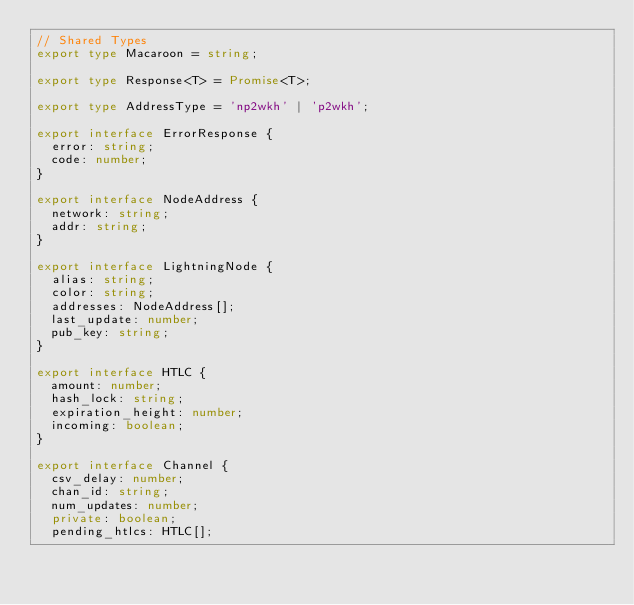<code> <loc_0><loc_0><loc_500><loc_500><_TypeScript_>// Shared Types
export type Macaroon = string;

export type Response<T> = Promise<T>;

export type AddressType = 'np2wkh' | 'p2wkh';

export interface ErrorResponse {
  error: string;
  code: number;
}

export interface NodeAddress {
  network: string;
  addr: string;
}

export interface LightningNode {
  alias: string;
  color: string;
  addresses: NodeAddress[];
  last_update: number;
  pub_key: string;
}

export interface HTLC {
  amount: number;
  hash_lock: string;
  expiration_height: number;
  incoming: boolean;
}

export interface Channel {
  csv_delay: number;
  chan_id: string;
  num_updates: number;
  private: boolean;
  pending_htlcs: HTLC[];</code> 